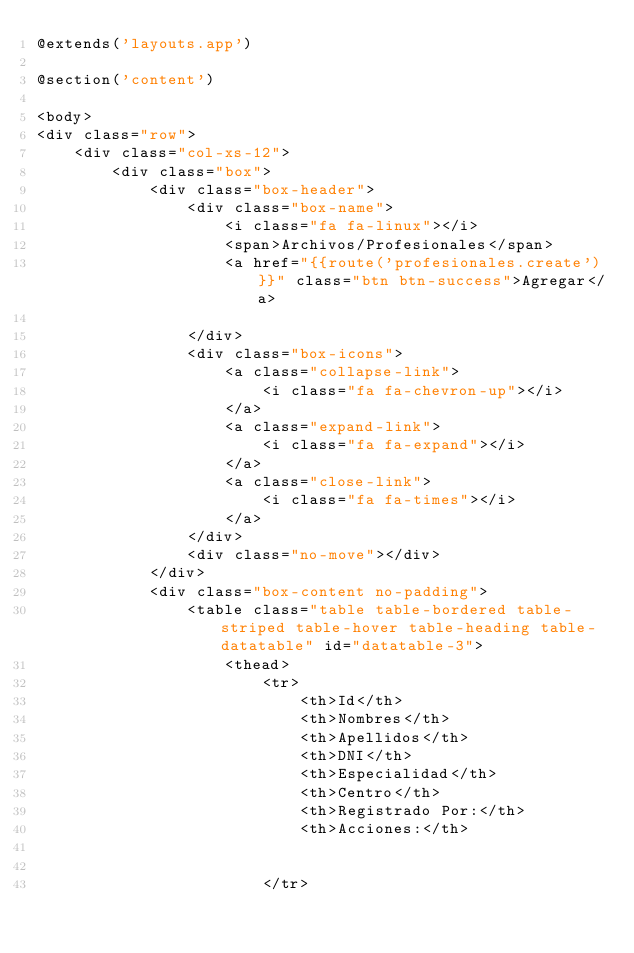<code> <loc_0><loc_0><loc_500><loc_500><_PHP_>@extends('layouts.app')

@section('content')

<body>
<div class="row">
	<div class="col-xs-12">
		<div class="box">
			<div class="box-header">
				<div class="box-name">
					<i class="fa fa-linux"></i>
					<span>Archivos/Profesionales</span>
				    <a href="{{route('profesionales.create')}}" class="btn btn-success">Agregar</a>

				</div>
				<div class="box-icons">
					<a class="collapse-link">
						<i class="fa fa-chevron-up"></i>
					</a>
					<a class="expand-link">
						<i class="fa fa-expand"></i>
					</a>
					<a class="close-link">
						<i class="fa fa-times"></i>
					</a>
				</div>
				<div class="no-move"></div>
			</div>
			<div class="box-content no-padding">
				<table class="table table-bordered table-striped table-hover table-heading table-datatable" id="datatable-3">
					<thead>
						<tr>
							<th>Id</th>
							<th>Nombres</th>
							<th>Apellidos</th>
							<th>DNI</th>
							<th>Especialidad</th>
							<th>Centro</th>
							<th>Registrado Por:</th>
							<th>Acciones:</th>


						</tr></code> 